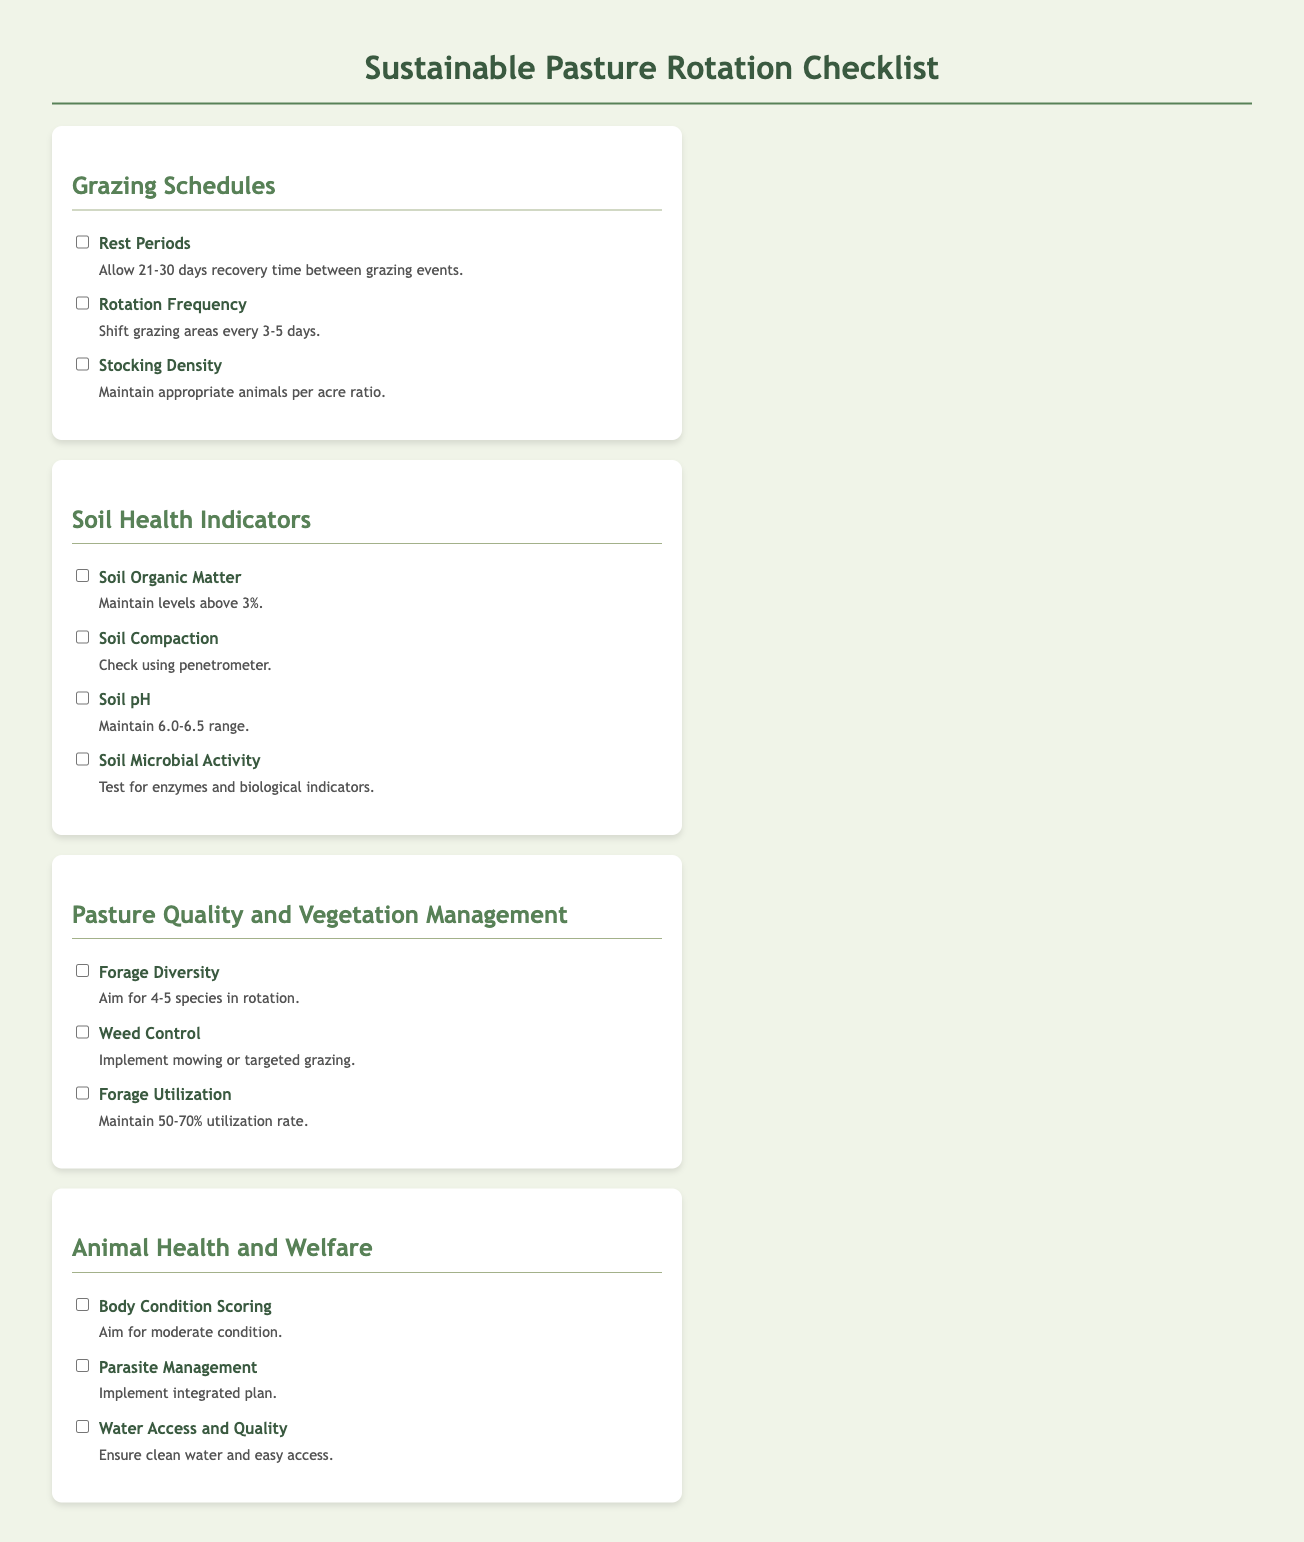What is the recovery time required between grazing events? The document specifies that there should be a recovery time of 21-30 days between grazing events.
Answer: 21-30 days How often should grazing areas be rotated? The document mentions that grazing areas should be shifted every 3-5 days.
Answer: 3-5 days What is the minimum soil organic matter percentage? According to the checklist, the soil organic matter levels should be maintained above 3%.
Answer: above 3% What should be the pH range for the soil? The document states that the soil pH should be maintained within the range of 6.0-6.5.
Answer: 6.0-6.5 What is the ideal number of forage species in rotation? The checklist aims for a diversity of 4-5 species in rotation for forage.
Answer: 4-5 species What is the recommended forage utilization rate? The document suggests maintaining a forage utilization rate of 50-70%.
Answer: 50-70% What condition should animals aim for in body condition scoring? The body condition scoring target is mentioned as aiming for a moderate condition.
Answer: moderate What is the purpose of using a penetrometer? The document indicates that a penetrometer is used to check for soil compaction.
Answer: check soil compaction What should be ensured regarding water access for animals? It emphasizes the need for clean water and easy access for animals.
Answer: clean water and easy access 